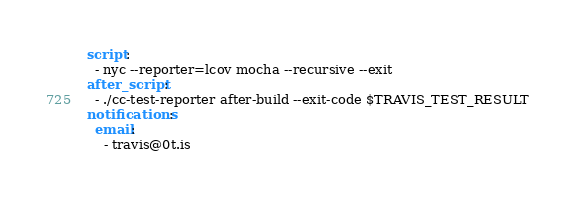Convert code to text. <code><loc_0><loc_0><loc_500><loc_500><_YAML_>script:
  - nyc --reporter=lcov mocha --recursive --exit
after_script:
  - ./cc-test-reporter after-build --exit-code $TRAVIS_TEST_RESULT
notifications:
  email:
    - travis@0t.is</code> 